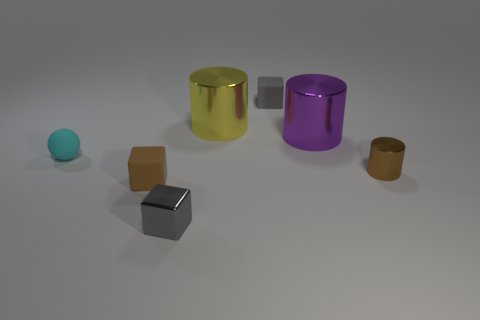Subtract 1 cubes. How many cubes are left? 2 Add 3 small brown rubber blocks. How many objects exist? 10 Subtract all spheres. How many objects are left? 6 Subtract 0 red balls. How many objects are left? 7 Subtract all brown blocks. Subtract all gray rubber objects. How many objects are left? 5 Add 3 cylinders. How many cylinders are left? 6 Add 5 gray objects. How many gray objects exist? 7 